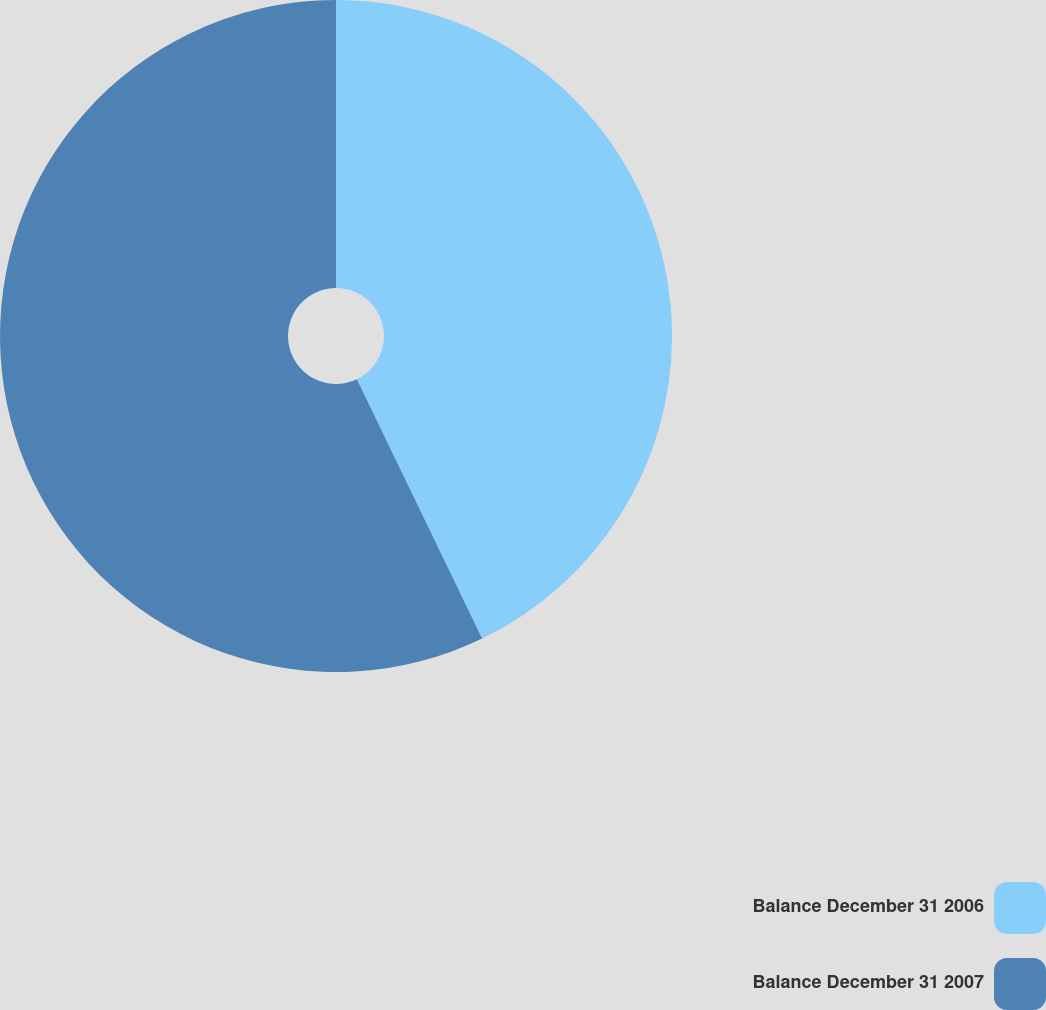Convert chart to OTSL. <chart><loc_0><loc_0><loc_500><loc_500><pie_chart><fcel>Balance December 31 2006<fcel>Balance December 31 2007<nl><fcel>42.84%<fcel>57.16%<nl></chart> 